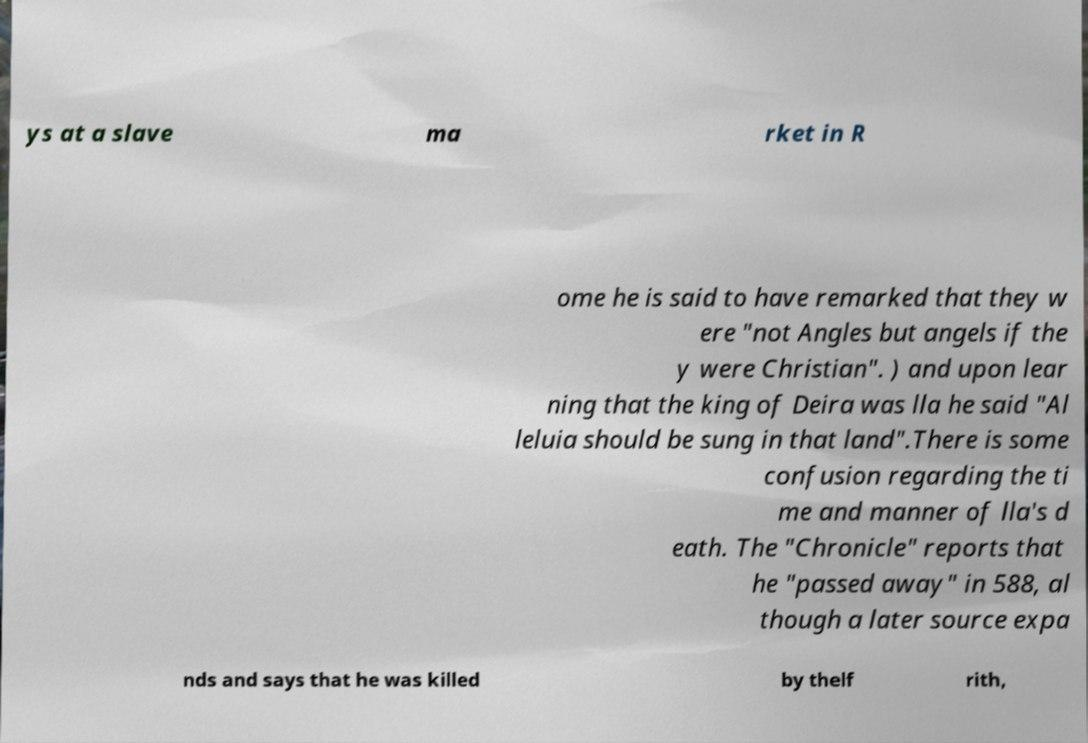Can you read and provide the text displayed in the image?This photo seems to have some interesting text. Can you extract and type it out for me? ys at a slave ma rket in R ome he is said to have remarked that they w ere "not Angles but angels if the y were Christian". ) and upon lear ning that the king of Deira was lla he said "Al leluia should be sung in that land".There is some confusion regarding the ti me and manner of lla's d eath. The "Chronicle" reports that he "passed away" in 588, al though a later source expa nds and says that he was killed by thelf rith, 